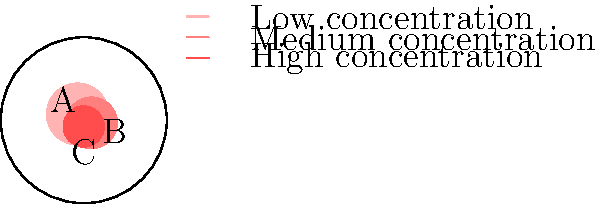Based on the map showing areas with struggling businesses in our city, which zone should be prioritized for immediate financial relief and resources? Justify your answer considering the concentration of struggling businesses and potential impact on the local economy. To determine which zone should be prioritized for immediate financial relief and resources, we need to analyze the map and consider the following factors:

1. Concentration of struggling businesses: The darker the red color, the higher the concentration of struggling businesses.

2. Size of the affected area: Larger areas may indicate a more widespread problem affecting more businesses.

3. Potential impact on the local economy: Areas with higher concentrations and larger sizes may have a more significant impact on the overall local economy.

Analyzing the map:

1. Area A: Light red, largest size
2. Area B: Medium red, medium size
3. Area C: Dark red, smallest size

Step-by-step evaluation:

1. Area C has the highest concentration of struggling businesses (darkest red), indicating a severe problem in a localized area.
2. Area B has a medium concentration and size, suggesting a moderate but potentially widespread issue.
3. Area A has the lowest concentration but covers the largest area, indicating a less severe but more extensive problem.

Considering the immediate need for financial relief and resources, Area C should be prioritized because:

1. It has the highest concentration of struggling businesses, indicating an urgent need for assistance.
2. Targeting a smaller area with a high concentration may lead to more efficient use of resources and quicker results.
3. Addressing the most severely affected area first may prevent further deterioration of the local economy and potentially have a ripple effect on surrounding areas.

While Areas A and B also require attention, the immediate focus should be on Area C to address the most critical situation first.
Answer: Area C 